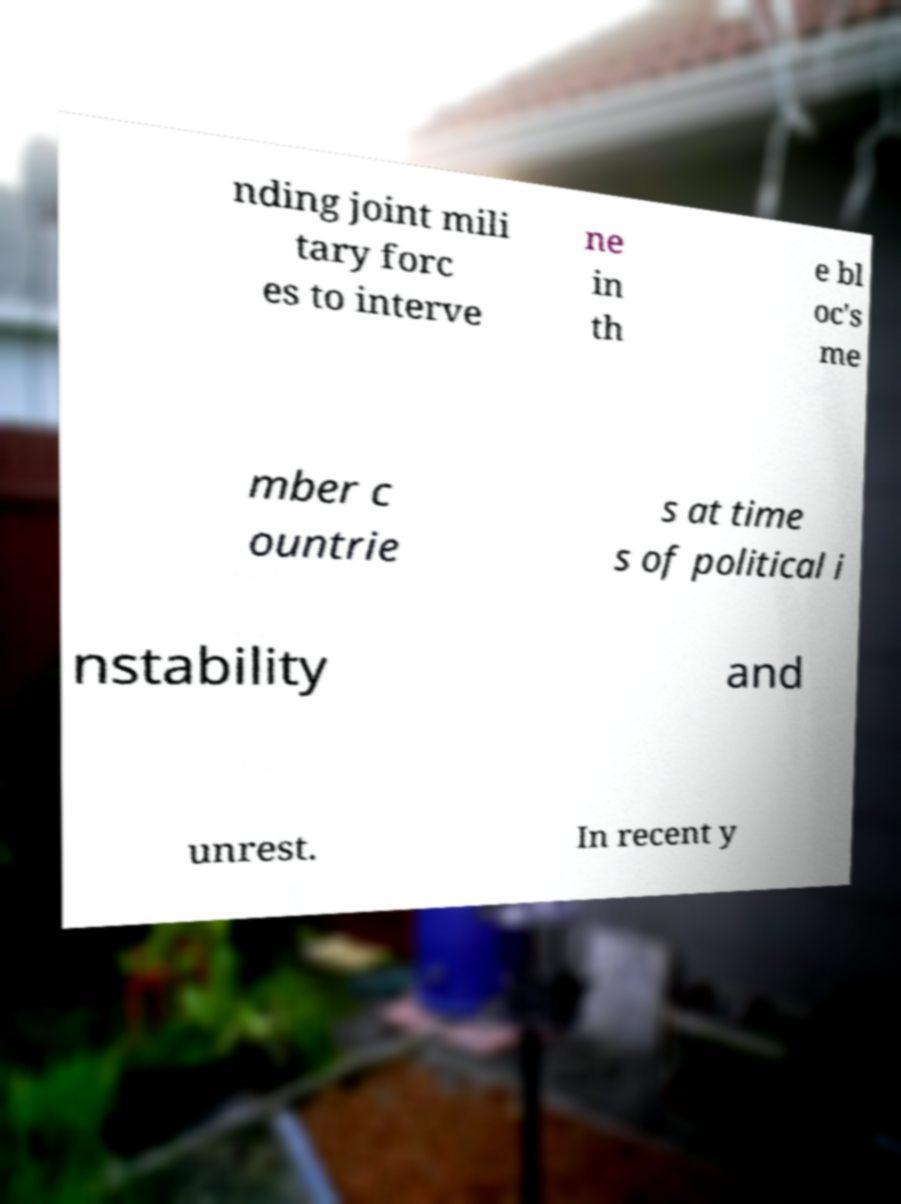For documentation purposes, I need the text within this image transcribed. Could you provide that? nding joint mili tary forc es to interve ne in th e bl oc's me mber c ountrie s at time s of political i nstability and unrest. In recent y 